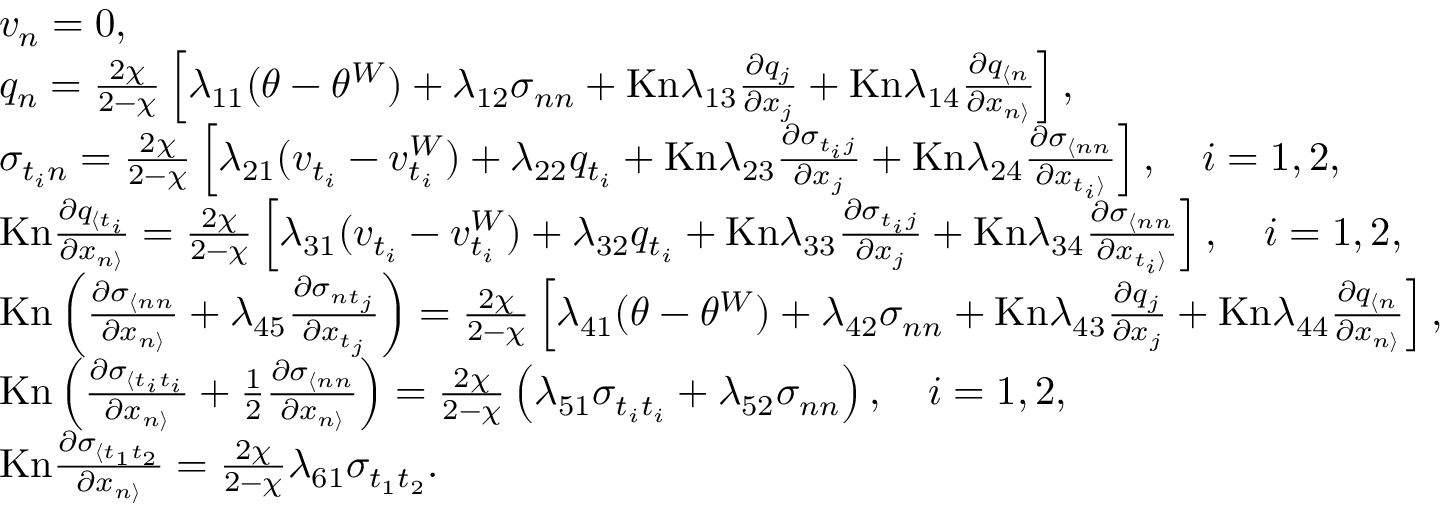<formula> <loc_0><loc_0><loc_500><loc_500>\begin{array} { r l } & { v _ { n } = 0 , } \\ & { q _ { n } = \frac { 2 \chi } { 2 - \chi } \left [ \lambda _ { 1 1 } ( \theta - \theta ^ { W } ) + \lambda _ { 1 2 } \sigma _ { n n } + K n \lambda _ { 1 3 } \frac { \partial q _ { j } } { \partial x _ { j } } + K n \lambda _ { 1 4 } \frac { \partial q _ { \langle n } } { \partial x _ { n \rangle } } \right ] , } \\ & { \sigma _ { t _ { i } n } = \frac { 2 \chi } { 2 - \chi } \left [ \lambda _ { 2 1 } ( v _ { t _ { i } } - v _ { t _ { i } } ^ { W } ) + \lambda _ { 2 2 } q _ { t _ { i } } + K n \lambda _ { 2 3 } \frac { \partial \sigma _ { t _ { i } j } } { \partial x _ { j } } + K n \lambda _ { 2 4 } \frac { \partial \sigma _ { \langle n n } } { \partial x _ { t _ { i } \rangle } } \right ] , \quad i = 1 , 2 , } \\ & { K n \frac { \partial q _ { \langle t _ { i } } } { \partial x _ { n \rangle } } = \frac { 2 \chi } { 2 - \chi } \left [ \lambda _ { 3 1 } ( v _ { t _ { i } } - v _ { t _ { i } } ^ { W } ) + \lambda _ { 3 2 } q _ { t _ { i } } + K n \lambda _ { 3 3 } \frac { \partial \sigma _ { t _ { i } j } } { \partial x _ { j } } + K n \lambda _ { 3 4 } \frac { \partial \sigma _ { \langle n n } } { \partial x _ { t _ { i } \rangle } } \right ] , \quad i = 1 , 2 , } \\ & { K n \left ( \frac { \partial \sigma _ { \langle n n } } { \partial x _ { n \rangle } } + \lambda _ { 4 5 } \frac { \partial \sigma _ { n t _ { j } } } { \partial x _ { t _ { j } } } \right ) = \frac { 2 \chi } { 2 - \chi } \left [ \lambda _ { 4 1 } ( \theta - \theta ^ { W } ) + \lambda _ { 4 2 } \sigma _ { n n } + K n \lambda _ { 4 3 } \frac { \partial q _ { j } } { \partial x _ { j } } + K n \lambda _ { 4 4 } \frac { \partial q _ { \langle n } } { \partial x _ { n \rangle } } \right ] , } \\ & { K n \left ( \frac { \partial \sigma _ { \langle t _ { i } t _ { i } } } { \partial x _ { n \rangle } } + \frac { 1 } { 2 } \frac { \partial \sigma _ { \langle n n } } { \partial x _ { n \rangle } } \right ) = \frac { 2 \chi } { 2 - \chi } \left ( \lambda _ { 5 1 } \sigma _ { t _ { i } t _ { i } } + \lambda _ { 5 2 } \sigma _ { n n } \right ) , \quad i = 1 , 2 , } \\ & { K n \frac { \partial \sigma _ { \langle t _ { 1 } t _ { 2 } } } { \partial x _ { n \rangle } } = \frac { 2 \chi } { 2 - \chi } \lambda _ { 6 1 } \sigma _ { t _ { 1 } t _ { 2 } } . } \end{array}</formula> 